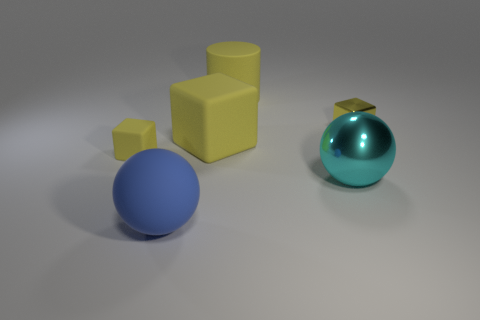Subtract all small yellow blocks. How many blocks are left? 1 Add 1 small yellow matte cubes. How many objects exist? 7 Subtract all spheres. How many objects are left? 4 Subtract all cyan cubes. Subtract all red cylinders. How many cubes are left? 3 Subtract 1 cyan balls. How many objects are left? 5 Subtract all yellow things. Subtract all small yellow shiny cubes. How many objects are left? 1 Add 5 tiny yellow objects. How many tiny yellow objects are left? 7 Add 6 small purple metallic things. How many small purple metallic things exist? 6 